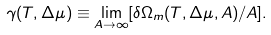Convert formula to latex. <formula><loc_0><loc_0><loc_500><loc_500>\gamma ( T , \Delta \mu ) \equiv \lim _ { A \rightarrow \infty } [ \delta \Omega _ { m } ( T , \Delta \mu , A ) / A ] .</formula> 